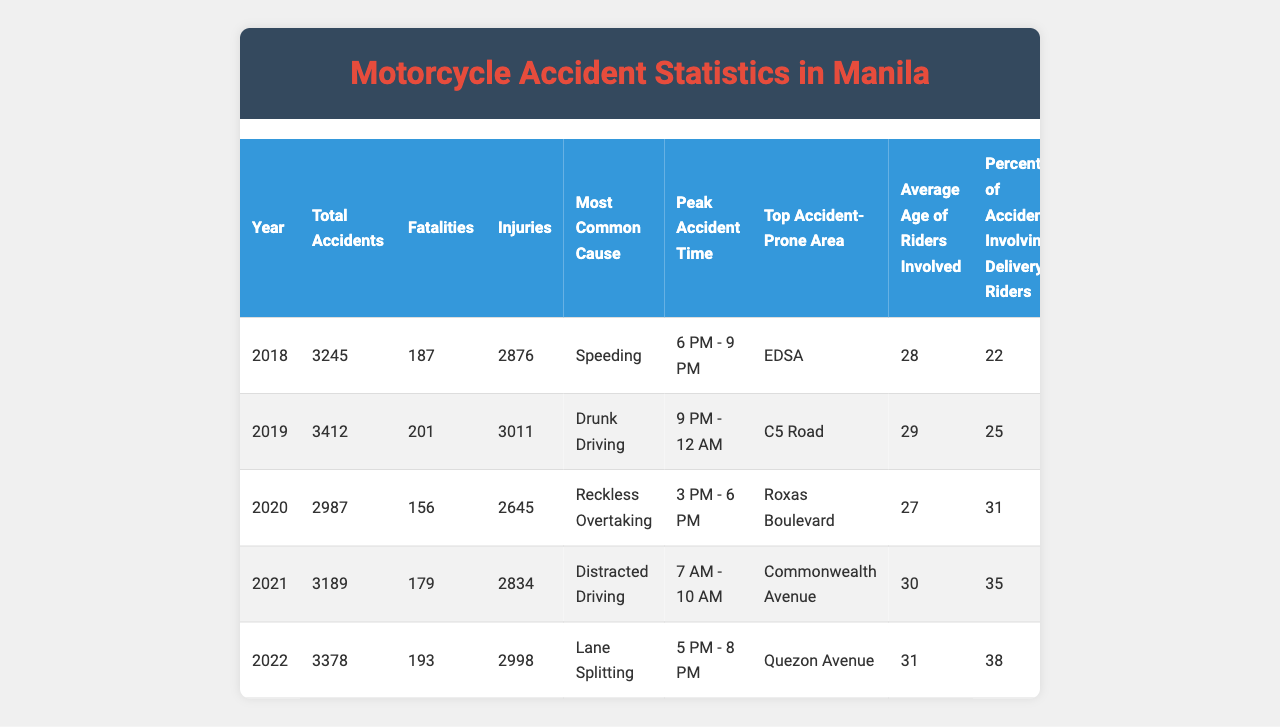What was the total number of motorcycle accidents in 2020? From the table, under the "Total Accidents" column for the year 2020, the value is listed as 2987.
Answer: 2987 Which year had the highest number of fatalities? By comparing the "Fatalities" column for each year, 2019 has the highest number at 201.
Answer: 2019 What is the most common cause of motorcycle accidents in 2022? Referring to the "Most Common Cause" column for the year 2022, it is noted as "Lane Splitting."
Answer: Lane Splitting What was the average age of riders involved in accidents across all years? The average age can be calculated by summing the average ages (28 + 29 + 27 + 30 + 31 = 145) and dividing by 5 (total years) which equals 29.
Answer: 29 In which year was "Drunk Driving" the most common cause of accidents? Checking the "Most Common Cause" column reveals that "Drunk Driving" was the most common in 2019.
Answer: 2019 Is the percentage of accidents involving delivery riders increasing over the years? Looking at the "Percentage of Accidents Involving Delivery Riders," the values are 22%, 25%, 31%, 35%, and 38% from 2018 to 2022, which shows an increase each year. Thus, the answer is yes.
Answer: Yes What was the peak accident time in 2021? From the "Peak Accident Time" column for 2021, the time listed is "7 AM - 10 AM."
Answer: 7 AM - 10 AM What is the difference in total accidents between 2018 and 2022? The total number of accidents in 2018 is 3245, and in 2022 is 3378. The difference is 3378 - 3245 = 133.
Answer: 133 In which area did the highest number of accidents occur in the past 5 years? By checking the "Top Accident-Prone Area" column, EDSA is mentioned in 2018, but it is not clear if it's the highest overall; we need to compare other areas. Most common areas over the years: EDSA, C5 Road, Roxas Boulevard, Commonwealth Avenue, Quezon Avenue. Commonwealth Avenue and Quezon Avenue in later years might have had higher accidents. This question needs careful consideration of data.
Answer: No clear answer; all areas vary across years Was there a year with fewer accidents compared to the previous year? Comparing total accidents each year: 2018 to 2019 increased, 2019 to 2020 decreased (3412 to 2987), then increased again in 2021 and 2022. Therefore, there was a decrease in 2020.
Answer: Yes 